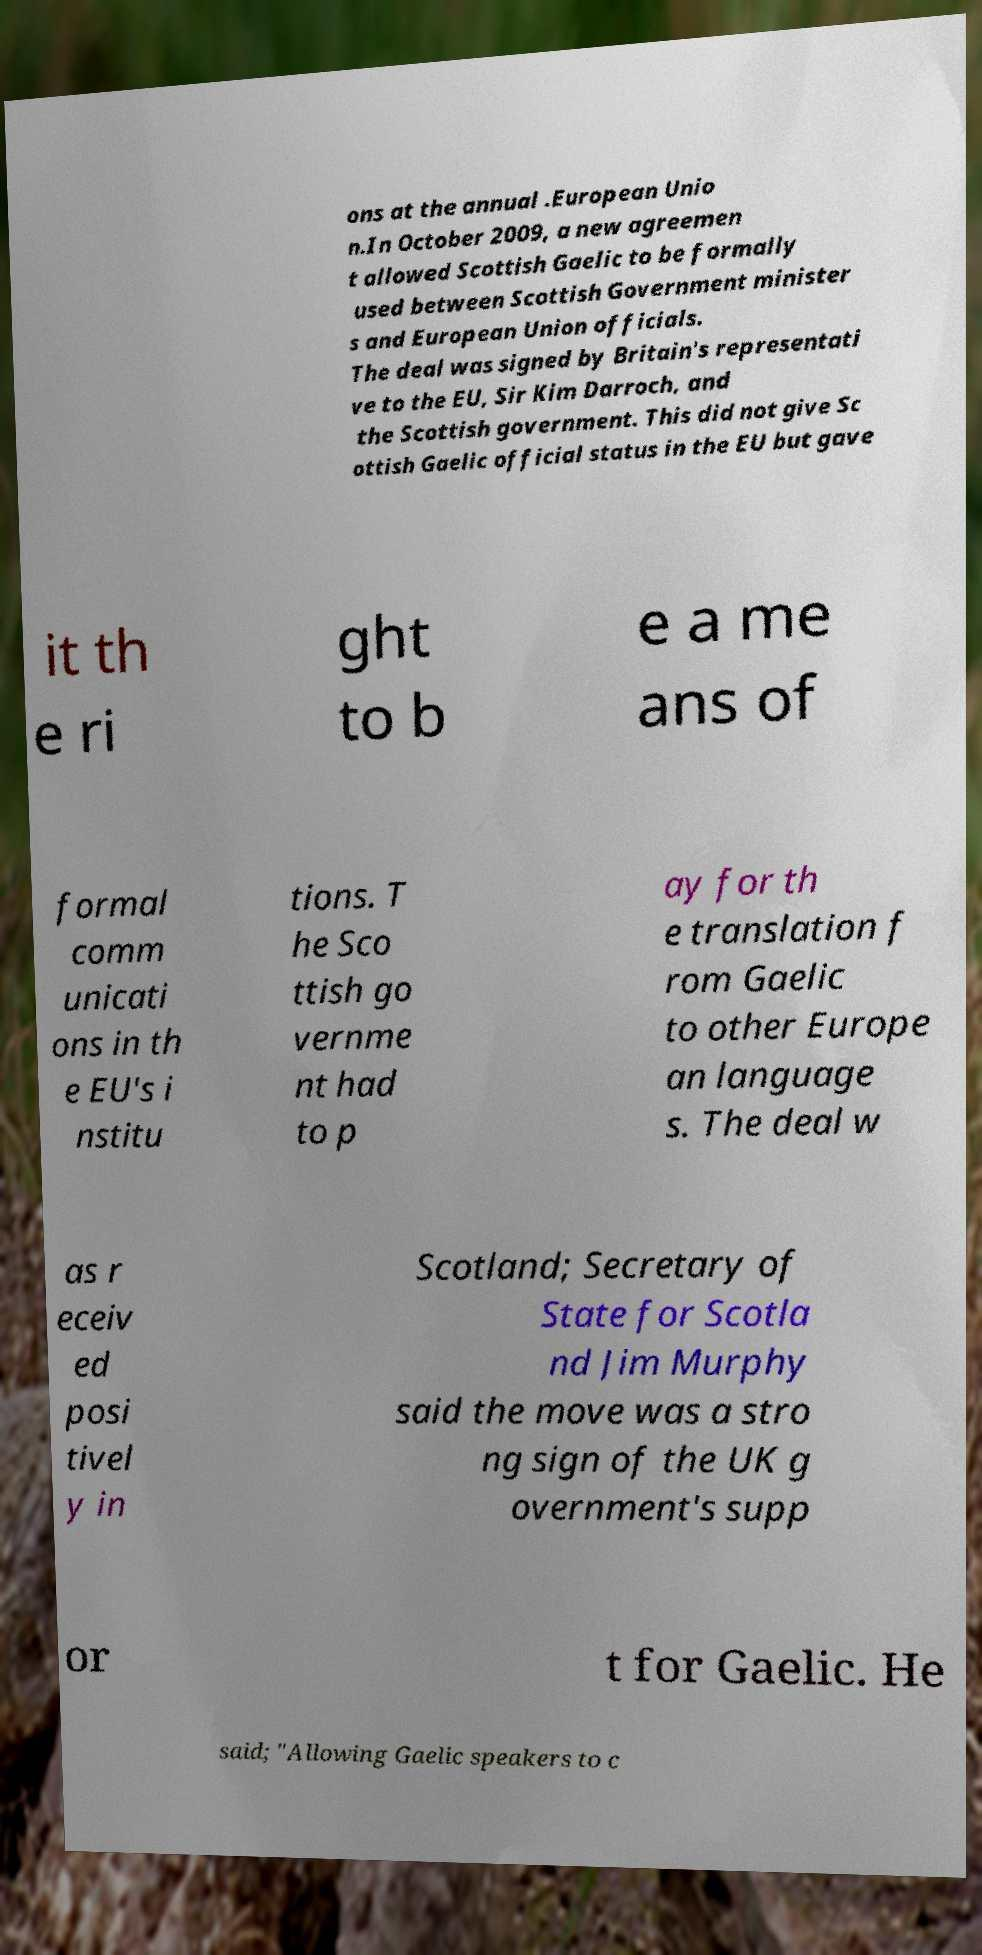Could you extract and type out the text from this image? ons at the annual .European Unio n.In October 2009, a new agreemen t allowed Scottish Gaelic to be formally used between Scottish Government minister s and European Union officials. The deal was signed by Britain's representati ve to the EU, Sir Kim Darroch, and the Scottish government. This did not give Sc ottish Gaelic official status in the EU but gave it th e ri ght to b e a me ans of formal comm unicati ons in th e EU's i nstitu tions. T he Sco ttish go vernme nt had to p ay for th e translation f rom Gaelic to other Europe an language s. The deal w as r eceiv ed posi tivel y in Scotland; Secretary of State for Scotla nd Jim Murphy said the move was a stro ng sign of the UK g overnment's supp or t for Gaelic. He said; "Allowing Gaelic speakers to c 